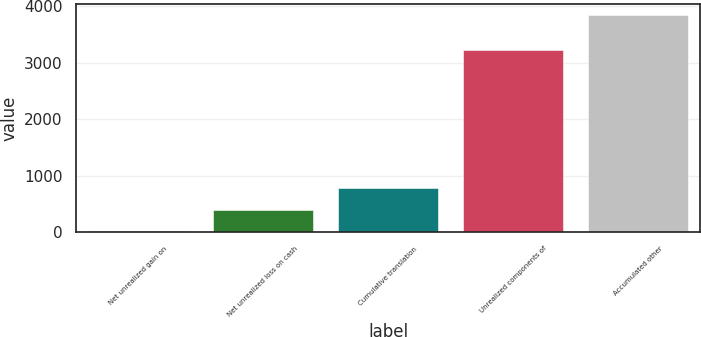Convert chart to OTSL. <chart><loc_0><loc_0><loc_500><loc_500><bar_chart><fcel>Net unrealized gain on<fcel>Net unrealized loss on cash<fcel>Cumulative translation<fcel>Unrealized components of<fcel>Accumulated other<nl><fcel>20<fcel>401.7<fcel>783.4<fcel>3225<fcel>3837<nl></chart> 